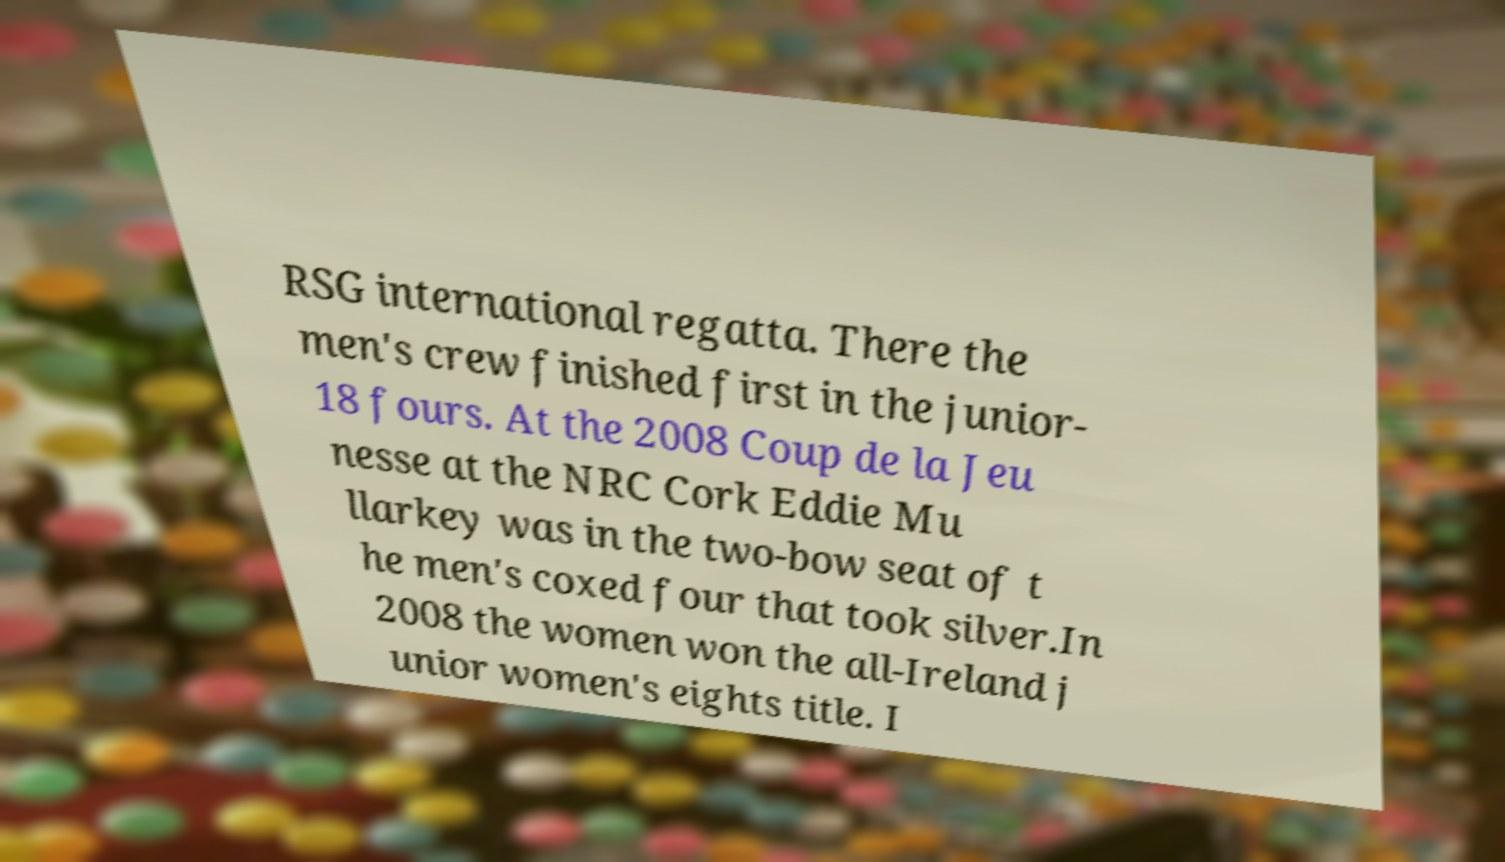Could you assist in decoding the text presented in this image and type it out clearly? RSG international regatta. There the men's crew finished first in the junior- 18 fours. At the 2008 Coup de la Jeu nesse at the NRC Cork Eddie Mu llarkey was in the two-bow seat of t he men's coxed four that took silver.In 2008 the women won the all-Ireland j unior women's eights title. I 